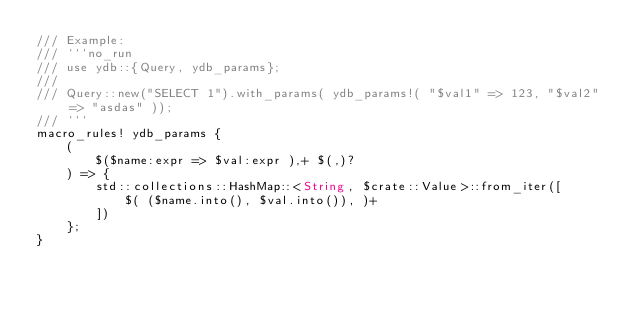Convert code to text. <code><loc_0><loc_0><loc_500><loc_500><_Rust_>/// Example:
/// ```no_run
/// use ydb::{Query, ydb_params};
///
/// Query::new("SELECT 1").with_params( ydb_params!( "$val1" => 123, "$val2" => "asdas" ));
/// ```
macro_rules! ydb_params {
    (
        $($name:expr => $val:expr ),+ $(,)?
    ) => {
        std::collections::HashMap::<String, $crate::Value>::from_iter([
            $( ($name.into(), $val.into()), )+
        ])
    };
}
</code> 